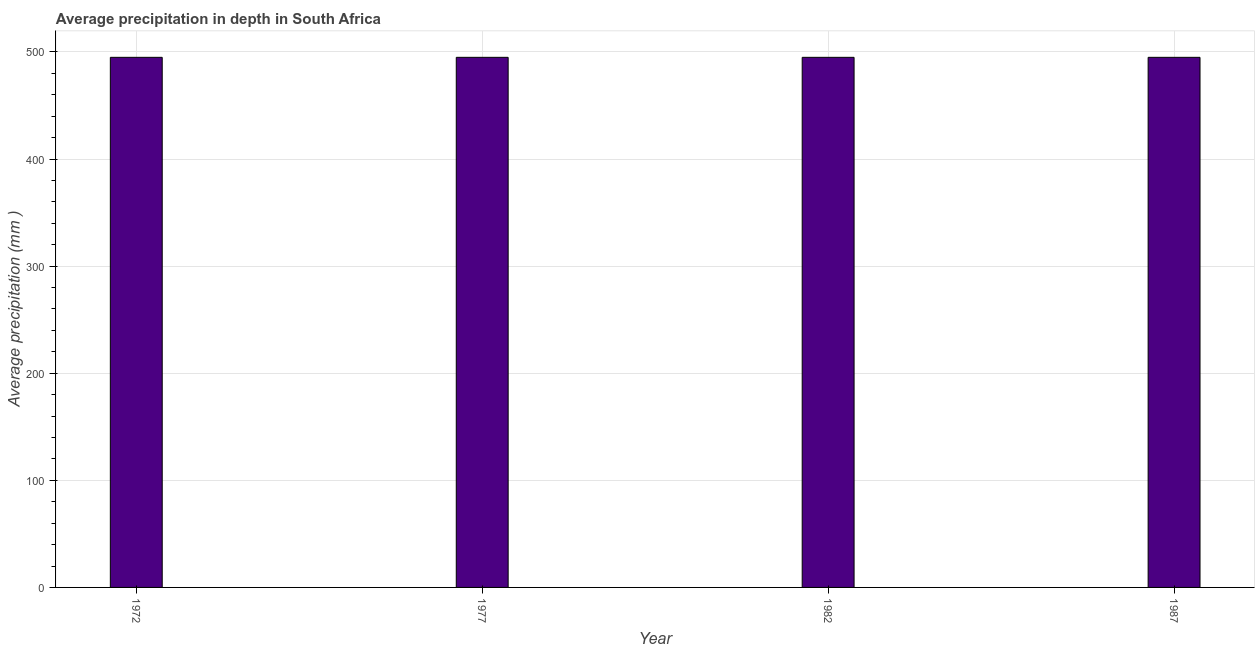Does the graph contain any zero values?
Give a very brief answer. No. What is the title of the graph?
Provide a succinct answer. Average precipitation in depth in South Africa. What is the label or title of the X-axis?
Ensure brevity in your answer.  Year. What is the label or title of the Y-axis?
Offer a very short reply. Average precipitation (mm ). What is the average precipitation in depth in 1982?
Offer a very short reply. 495. Across all years, what is the maximum average precipitation in depth?
Your answer should be compact. 495. Across all years, what is the minimum average precipitation in depth?
Give a very brief answer. 495. In which year was the average precipitation in depth maximum?
Make the answer very short. 1972. In which year was the average precipitation in depth minimum?
Make the answer very short. 1972. What is the sum of the average precipitation in depth?
Your response must be concise. 1980. What is the average average precipitation in depth per year?
Provide a succinct answer. 495. What is the median average precipitation in depth?
Offer a terse response. 495. In how many years, is the average precipitation in depth greater than 360 mm?
Offer a terse response. 4. What is the ratio of the average precipitation in depth in 1977 to that in 1987?
Offer a very short reply. 1. Is the difference between the average precipitation in depth in 1972 and 1982 greater than the difference between any two years?
Provide a succinct answer. Yes. Is the sum of the average precipitation in depth in 1972 and 1987 greater than the maximum average precipitation in depth across all years?
Offer a very short reply. Yes. How many bars are there?
Offer a terse response. 4. Are all the bars in the graph horizontal?
Your response must be concise. No. What is the Average precipitation (mm ) of 1972?
Offer a very short reply. 495. What is the Average precipitation (mm ) of 1977?
Make the answer very short. 495. What is the Average precipitation (mm ) of 1982?
Your answer should be compact. 495. What is the Average precipitation (mm ) in 1987?
Your answer should be compact. 495. What is the difference between the Average precipitation (mm ) in 1977 and 1987?
Offer a terse response. 0. What is the difference between the Average precipitation (mm ) in 1982 and 1987?
Offer a very short reply. 0. What is the ratio of the Average precipitation (mm ) in 1972 to that in 1982?
Keep it short and to the point. 1. What is the ratio of the Average precipitation (mm ) in 1972 to that in 1987?
Provide a short and direct response. 1. What is the ratio of the Average precipitation (mm ) in 1977 to that in 1982?
Your answer should be compact. 1. What is the ratio of the Average precipitation (mm ) in 1977 to that in 1987?
Give a very brief answer. 1. 